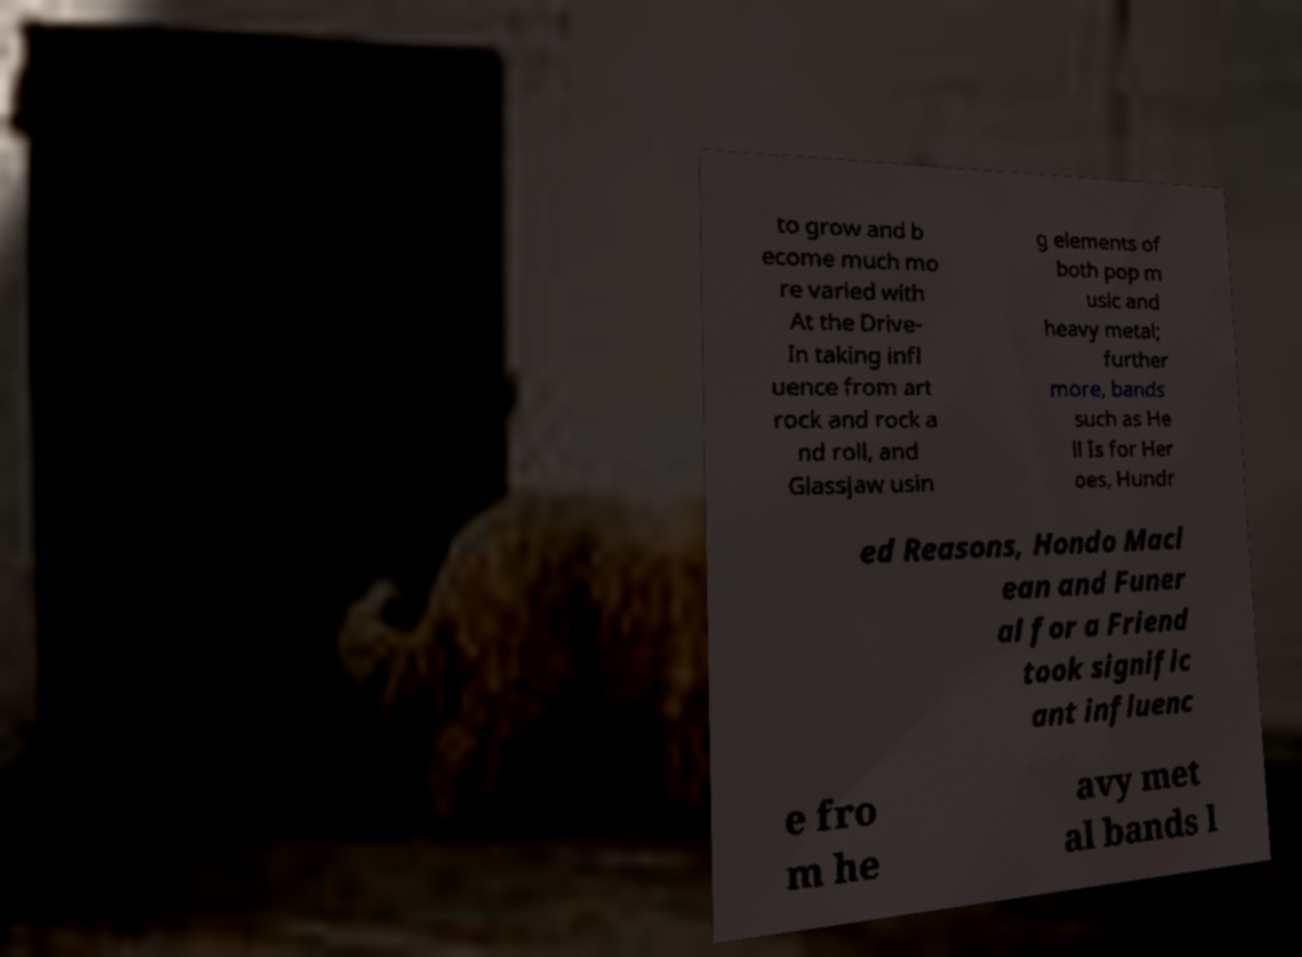I need the written content from this picture converted into text. Can you do that? to grow and b ecome much mo re varied with At the Drive- In taking infl uence from art rock and rock a nd roll, and Glassjaw usin g elements of both pop m usic and heavy metal; further more, bands such as He ll Is for Her oes, Hundr ed Reasons, Hondo Macl ean and Funer al for a Friend took signific ant influenc e fro m he avy met al bands l 